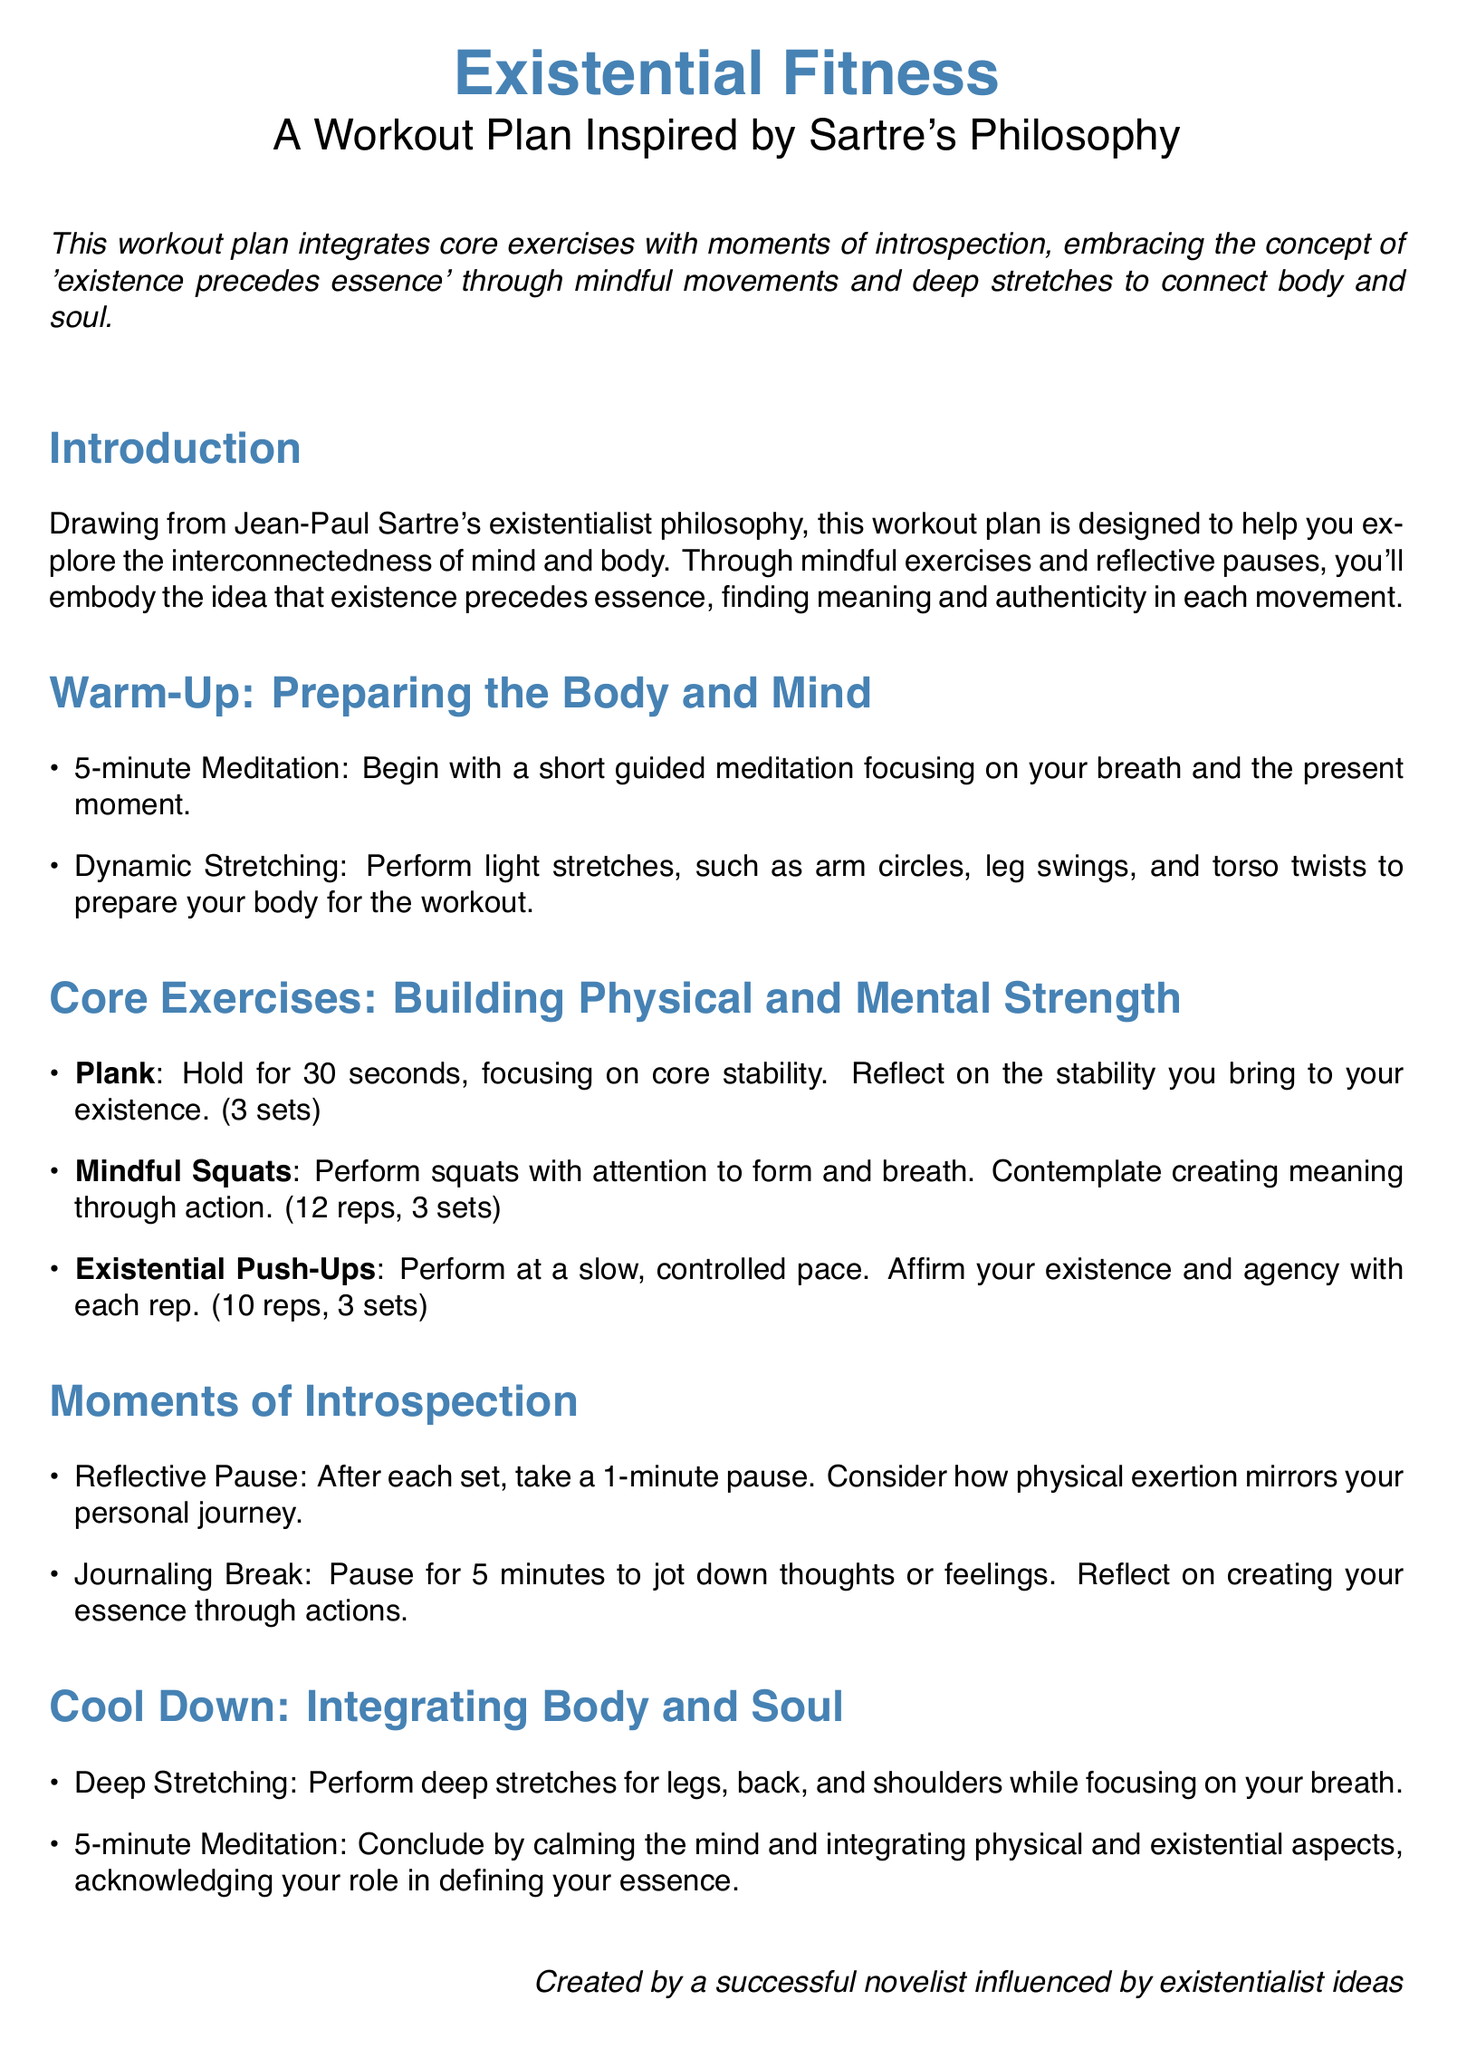What is the title of the workout plan? The title is prominently displayed at the top of the document.
Answer: Existential Fitness Who is the workout plan inspired by? The document states the inspiration source in the introduction.
Answer: Sartre's Philosophy How long should the plank be held? The document specifies the duration for holding the plank.
Answer: 30 seconds How many reps are suggested for mindful squats? The number of repetitions for mindful squats is mentioned in the core exercises section.
Answer: 12 reps What should you do after each set? The document outlines what to do following each set in the moments of introspection section.
Answer: Take a 1-minute pause What type of meditation is suggested in the cool down? The document specifies the type of meditation to be performed at the end of the workout.
Answer: 5-minute Meditation How many sets of existential push-ups are recommended? The number of sets for existential push-ups is detailed in the core exercises section.
Answer: 3 sets What does the plan aim to integrate? The purpose of the workout plan is mentioned in the introduction.
Answer: Body and soul What is the duration of the journaling break suggested? The document specifies the length of the journaling activity.
Answer: 5 minutes 